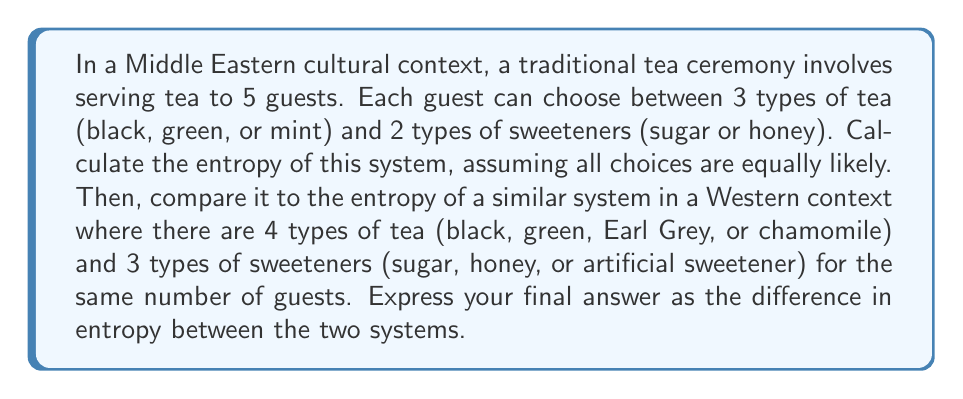Teach me how to tackle this problem. Let's approach this step-by-step:

1. For the Middle Eastern context:
   - Number of guests: 5
   - Number of tea choices: 3
   - Number of sweetener choices: 2
   
   Total number of possible states: $\Omega_M = (3 \times 2)^5 = 6^5$

   Entropy: $S_M = k_B \ln(\Omega_M) = k_B \ln(6^5)$

2. For the Western context:
   - Number of guests: 5
   - Number of tea choices: 4
   - Number of sweetener choices: 3
   
   Total number of possible states: $\Omega_W = (4 \times 3)^5 = 12^5$

   Entropy: $S_W = k_B \ln(\Omega_W) = k_B \ln(12^5)$

3. Calculate the difference in entropy:

   $$\Delta S = S_W - S_M = k_B \ln(12^5) - k_B \ln(6^5)$$

4. Using the logarithm property $\ln(a^b) = b\ln(a)$:

   $$\Delta S = k_B [5\ln(12) - 5\ln(6)]$$

5. Factor out the common terms:

   $$\Delta S = 5k_B [\ln(12) - \ln(6)]$$

6. Using the logarithm property $\ln(a) - \ln(b) = \ln(a/b)$:

   $$\Delta S = 5k_B \ln(12/6) = 5k_B \ln(2)$$
Answer: $5k_B \ln(2)$ 